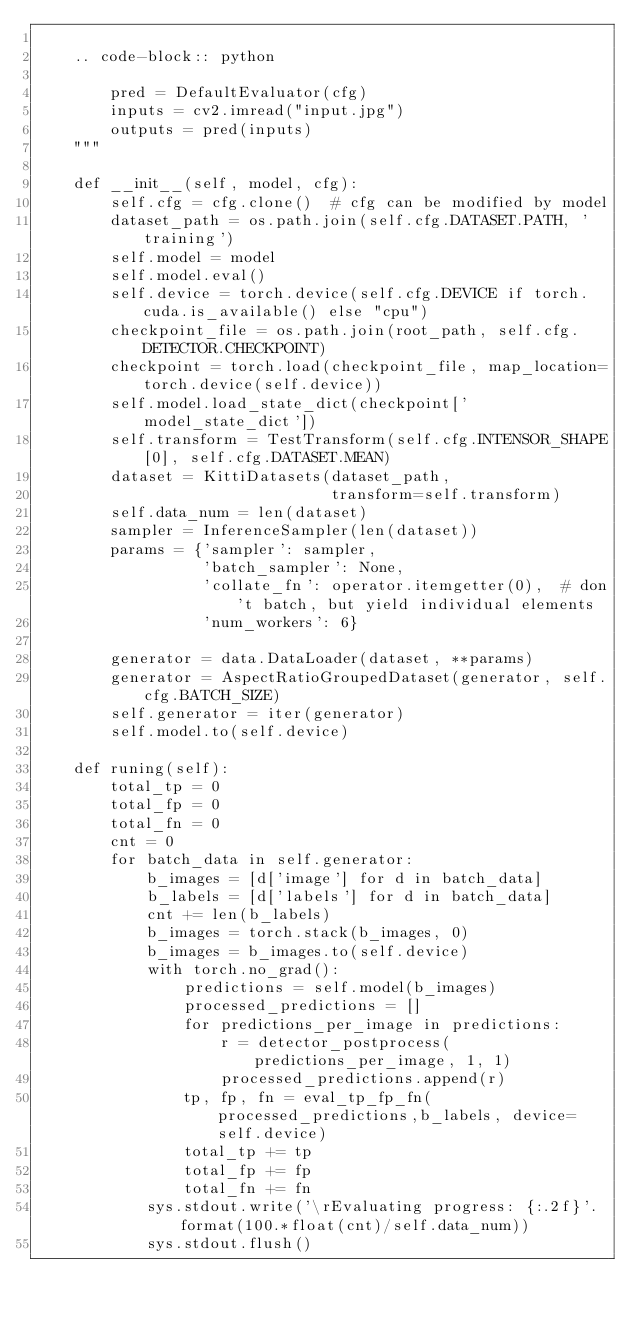Convert code to text. <code><loc_0><loc_0><loc_500><loc_500><_Python_>
    .. code-block:: python

        pred = DefaultEvaluator(cfg)
        inputs = cv2.imread("input.jpg")
        outputs = pred(inputs)
    """

    def __init__(self, model, cfg):
        self.cfg = cfg.clone()  # cfg can be modified by model
        dataset_path = os.path.join(self.cfg.DATASET.PATH, 'training')
        self.model = model
        self.model.eval()
        self.device = torch.device(self.cfg.DEVICE if torch.cuda.is_available() else "cpu")
        checkpoint_file = os.path.join(root_path, self.cfg.DETECTOR.CHECKPOINT)
        checkpoint = torch.load(checkpoint_file, map_location=torch.device(self.device))
        self.model.load_state_dict(checkpoint['model_state_dict'])
        self.transform = TestTransform(self.cfg.INTENSOR_SHAPE[0], self.cfg.DATASET.MEAN)
        dataset = KittiDatasets(dataset_path,
                                transform=self.transform)
        self.data_num = len(dataset)
        sampler = InferenceSampler(len(dataset))
        params = {'sampler': sampler,
                  'batch_sampler': None,
                  'collate_fn': operator.itemgetter(0),  # don't batch, but yield individual elements
                  'num_workers': 6}

        generator = data.DataLoader(dataset, **params)
        generator = AspectRatioGroupedDataset(generator, self.cfg.BATCH_SIZE)
        self.generator = iter(generator)
        self.model.to(self.device)

    def runing(self):
        total_tp = 0
        total_fp = 0
        total_fn = 0
        cnt = 0
        for batch_data in self.generator:
            b_images = [d['image'] for d in batch_data]
            b_labels = [d['labels'] for d in batch_data]
            cnt += len(b_labels)
            b_images = torch.stack(b_images, 0)
            b_images = b_images.to(self.device)
            with torch.no_grad():
                predictions = self.model(b_images)
                processed_predictions = []
                for predictions_per_image in predictions:
                    r = detector_postprocess(predictions_per_image, 1, 1)
                    processed_predictions.append(r)
                tp, fp, fn = eval_tp_fp_fn(processed_predictions,b_labels, device=self.device)
                total_tp += tp
                total_fp += fp
                total_fn += fn
            sys.stdout.write('\rEvaluating progress: {:.2f}'.format(100.*float(cnt)/self.data_num))
            sys.stdout.flush()</code> 